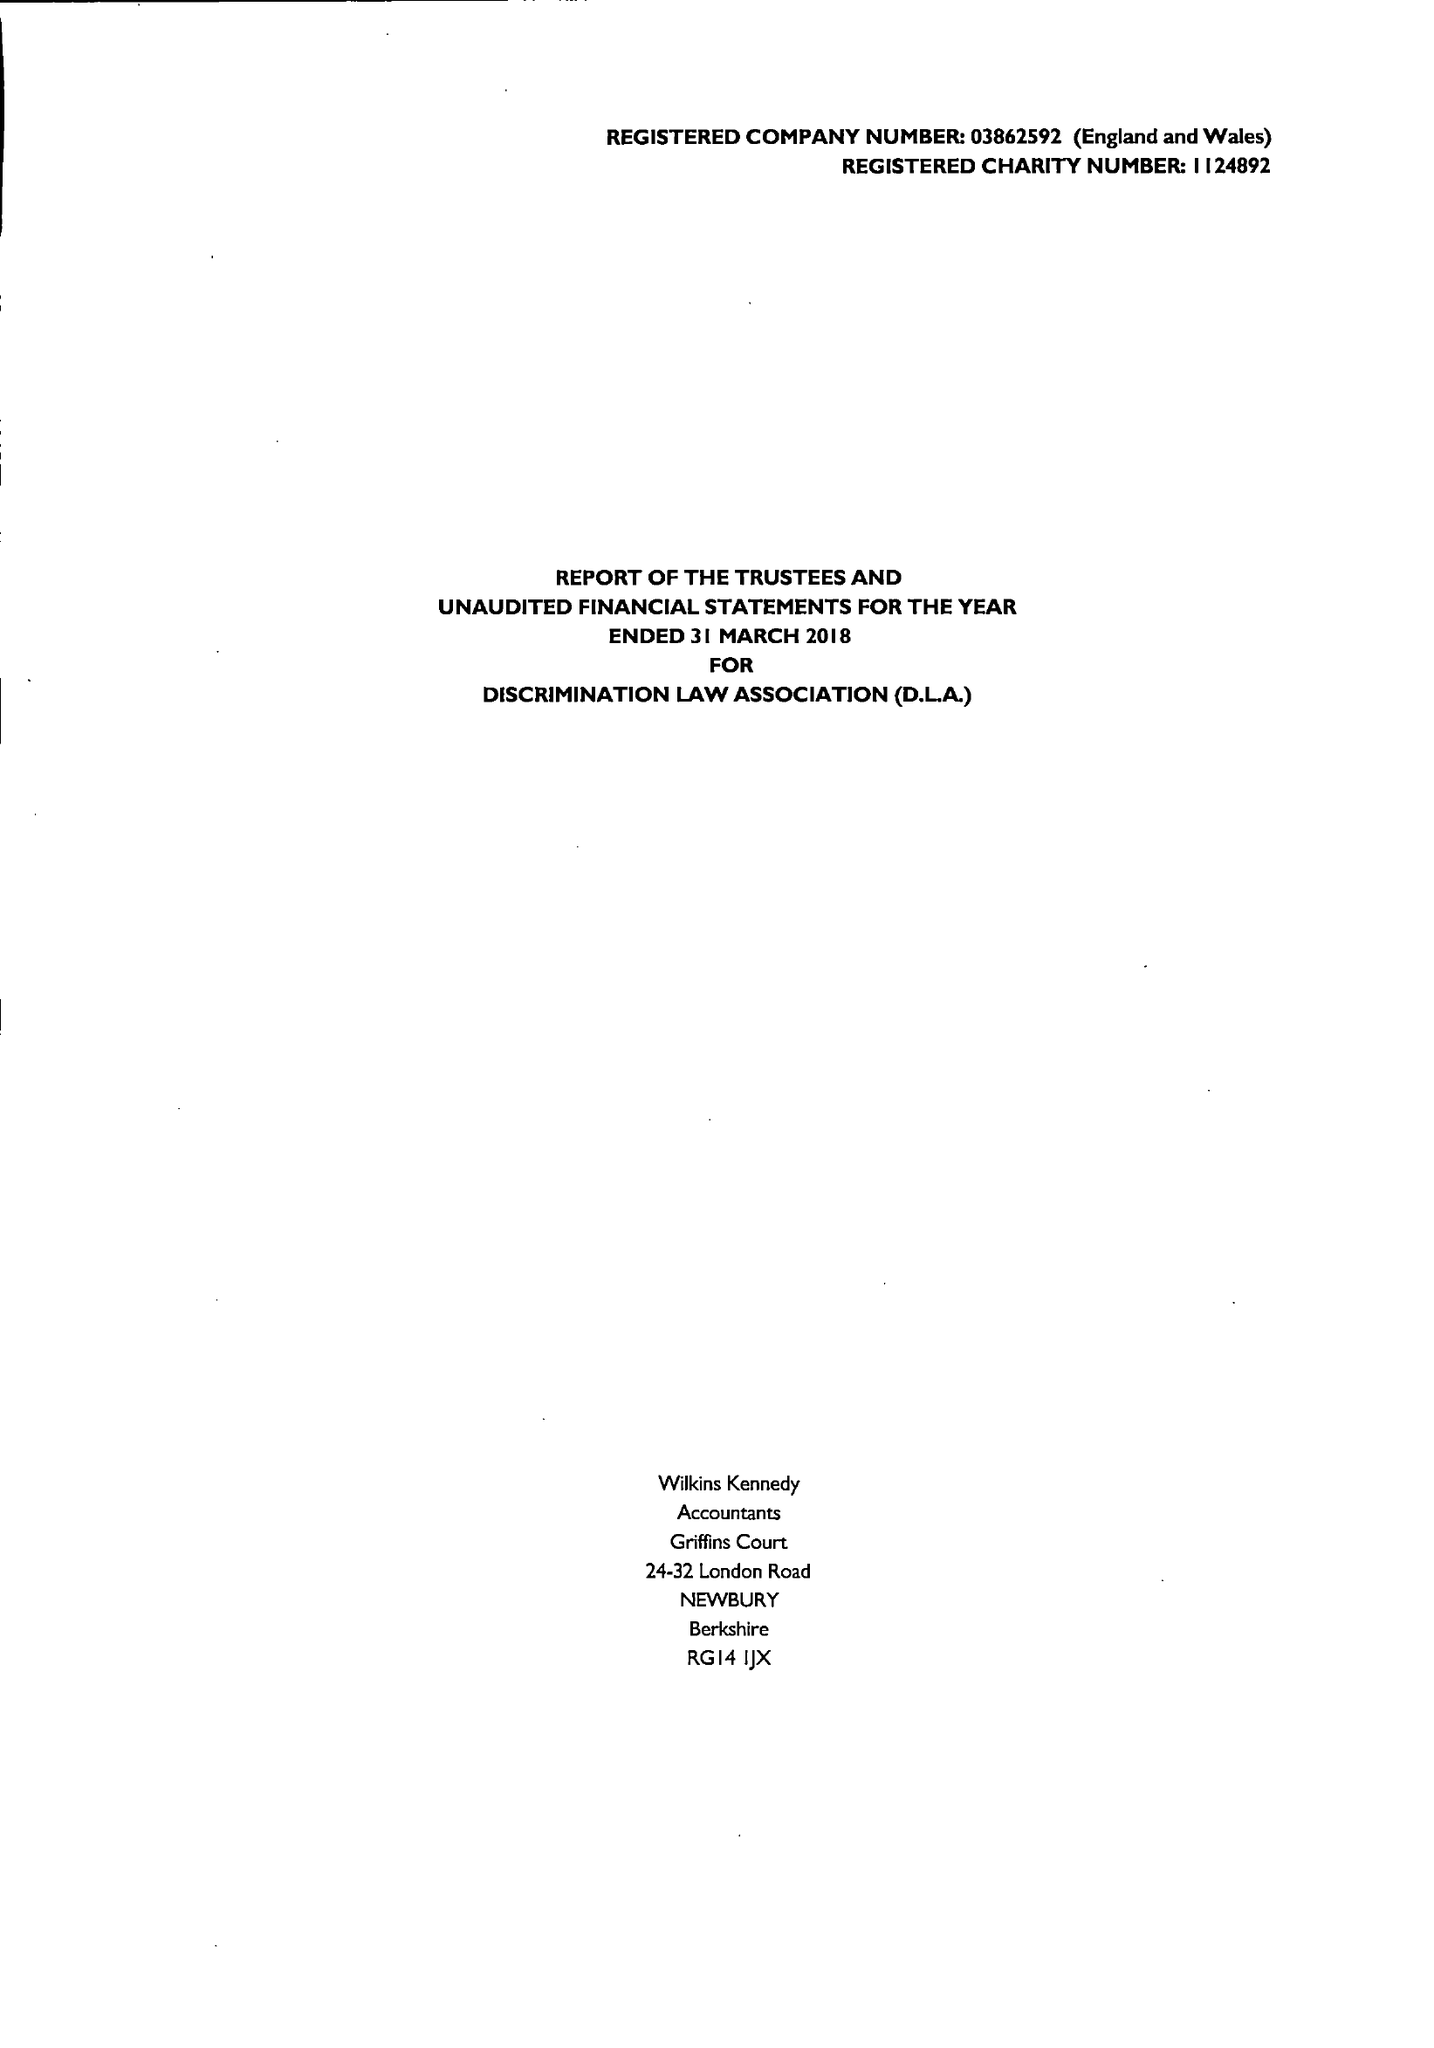What is the value for the charity_name?
Answer the question using a single word or phrase. Discrimination Law Association 